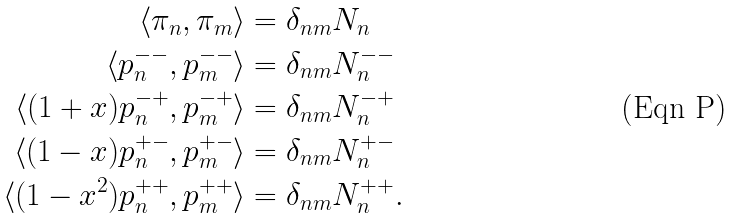<formula> <loc_0><loc_0><loc_500><loc_500>\langle \pi _ { n } , \pi _ { m } \rangle & = \delta _ { n m } N _ { n } \\ \langle p ^ { - - } _ { n } , p ^ { - - } _ { m } \rangle & = \delta _ { n m } N ^ { - - } _ { n } \\ \langle ( 1 + x ) p ^ { - + } _ { n } , p ^ { - + } _ { m } \rangle & = \delta _ { n m } N ^ { - + } _ { n } \\ \langle ( 1 - x ) p ^ { + - } _ { n } , p ^ { + - } _ { m } \rangle & = \delta _ { n m } N ^ { + - } _ { n } \\ \langle ( 1 - x ^ { 2 } ) p ^ { + + } _ { n } , p ^ { + + } _ { m } \rangle & = \delta _ { n m } N ^ { + + } _ { n } .</formula> 